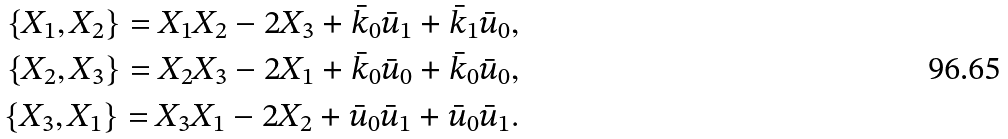<formula> <loc_0><loc_0><loc_500><loc_500>\{ X _ { 1 } , X _ { 2 } \} = X _ { 1 } X _ { 2 } - 2 X _ { 3 } + \bar { k } _ { 0 } \bar { u } _ { 1 } + \bar { k } _ { 1 } \bar { u } _ { 0 } , \\ \{ X _ { 2 } , X _ { 3 } \} = X _ { 2 } X _ { 3 } - 2 X _ { 1 } + \bar { k } _ { 0 } \bar { u } _ { 0 } + \bar { k } _ { 0 } \bar { u } _ { 0 } , \\ \{ X _ { 3 } , X _ { 1 } \} = X _ { 3 } X _ { 1 } - 2 X _ { 2 } + \bar { u } _ { 0 } \bar { u } _ { 1 } + \bar { u } _ { 0 } \bar { u } _ { 1 } .</formula> 